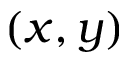<formula> <loc_0><loc_0><loc_500><loc_500>( x , y )</formula> 